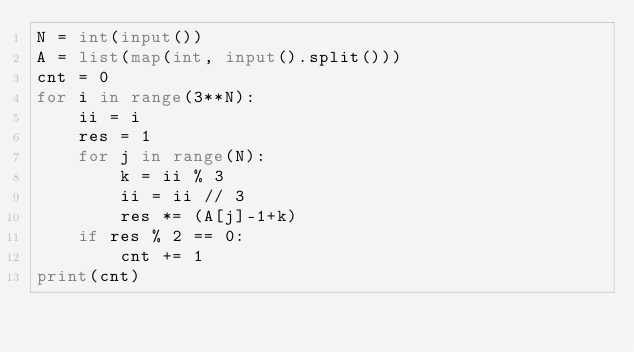Convert code to text. <code><loc_0><loc_0><loc_500><loc_500><_Python_>N = int(input())
A = list(map(int, input().split()))
cnt = 0
for i in range(3**N):
    ii = i
    res = 1
    for j in range(N):
        k = ii % 3
        ii = ii // 3
        res *= (A[j]-1+k)
    if res % 2 == 0:
        cnt += 1
print(cnt)</code> 